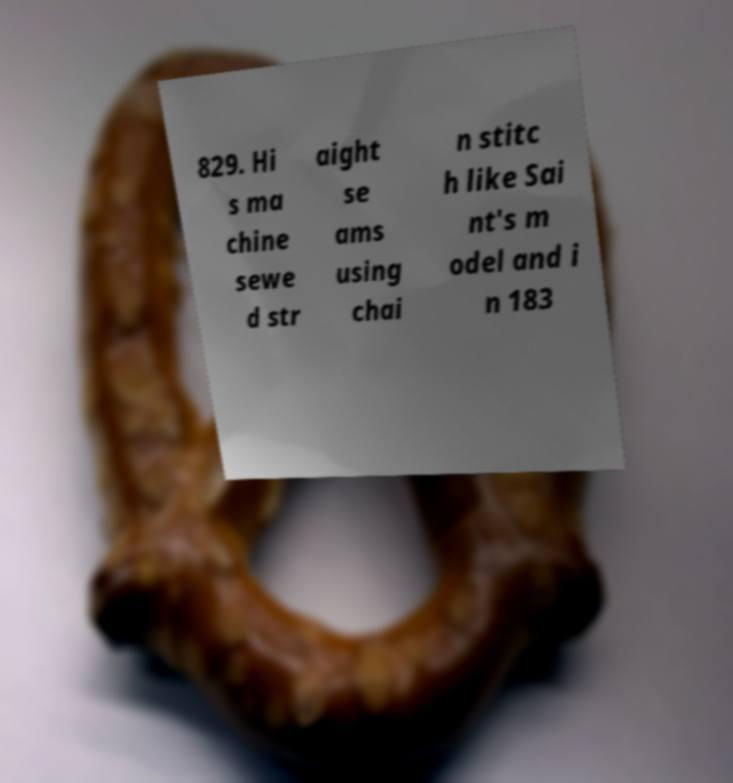Can you read and provide the text displayed in the image?This photo seems to have some interesting text. Can you extract and type it out for me? 829. Hi s ma chine sewe d str aight se ams using chai n stitc h like Sai nt's m odel and i n 183 